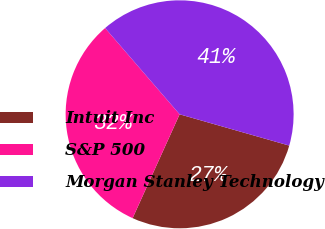<chart> <loc_0><loc_0><loc_500><loc_500><pie_chart><fcel>Intuit Inc<fcel>S&P 500<fcel>Morgan Stanley Technology<nl><fcel>27.34%<fcel>31.89%<fcel>40.76%<nl></chart> 